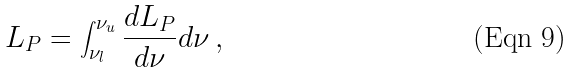Convert formula to latex. <formula><loc_0><loc_0><loc_500><loc_500>L _ { P } = \int _ { \nu _ { l } } ^ { \nu _ { u } } \frac { d L _ { P } } { d \nu } d \nu \, ,</formula> 